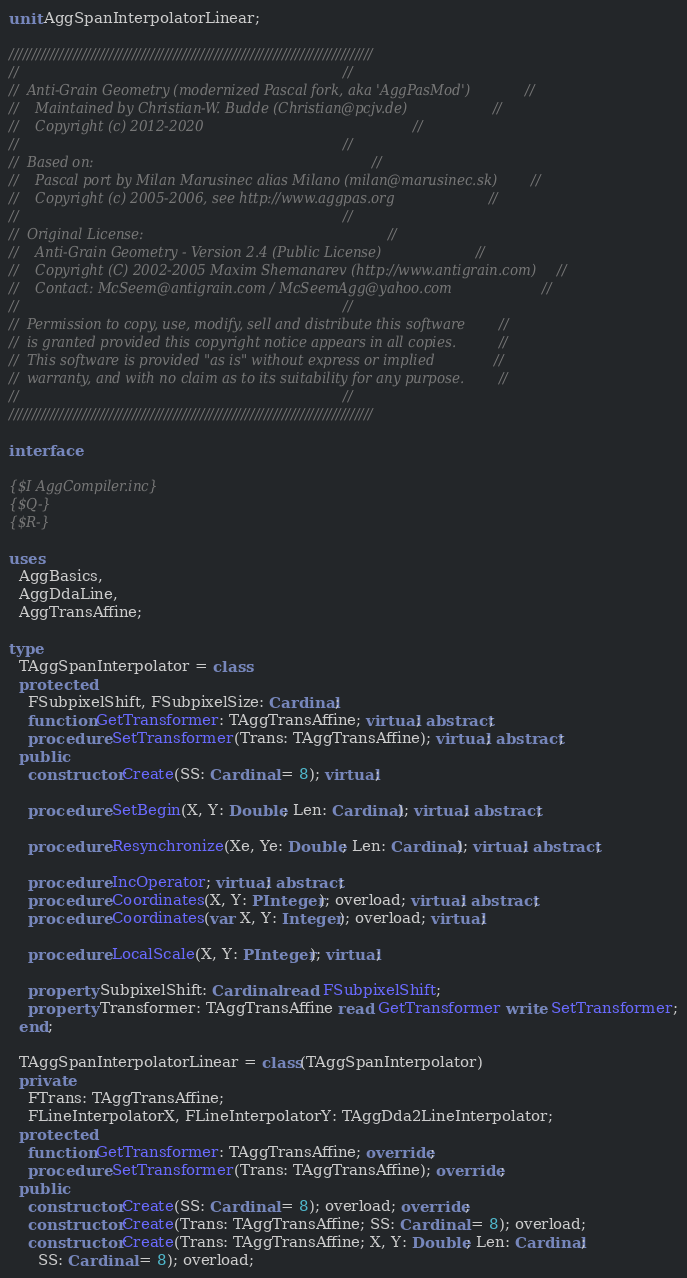Convert code to text. <code><loc_0><loc_0><loc_500><loc_500><_Pascal_>unit AggSpanInterpolatorLinear;

////////////////////////////////////////////////////////////////////////////////
//                                                                            //
//  Anti-Grain Geometry (modernized Pascal fork, aka 'AggPasMod')             //
//    Maintained by Christian-W. Budde (Christian@pcjv.de)                    //
//    Copyright (c) 2012-2020                                                 //
//                                                                            //
//  Based on:                                                                 //
//    Pascal port by Milan Marusinec alias Milano (milan@marusinec.sk)        //
//    Copyright (c) 2005-2006, see http://www.aggpas.org                      //
//                                                                            //
//  Original License:                                                         //
//    Anti-Grain Geometry - Version 2.4 (Public License)                      //
//    Copyright (C) 2002-2005 Maxim Shemanarev (http://www.antigrain.com)     //
//    Contact: McSeem@antigrain.com / McSeemAgg@yahoo.com                     //
//                                                                            //
//  Permission to copy, use, modify, sell and distribute this software        //
//  is granted provided this copyright notice appears in all copies.          //
//  This software is provided "as is" without express or implied              //
//  warranty, and with no claim as to its suitability for any purpose.        //
//                                                                            //
////////////////////////////////////////////////////////////////////////////////

interface

{$I AggCompiler.inc}
{$Q-}
{$R-}

uses
  AggBasics,
  AggDdaLine,
  AggTransAffine;

type
  TAggSpanInterpolator = class
  protected
    FSubpixelShift, FSubpixelSize: Cardinal;
    function GetTransformer: TAggTransAffine; virtual; abstract;
    procedure SetTransformer(Trans: TAggTransAffine); virtual; abstract;
  public
    constructor Create(SS: Cardinal = 8); virtual;

    procedure SetBegin(X, Y: Double; Len: Cardinal); virtual; abstract;

    procedure Resynchronize(Xe, Ye: Double; Len: Cardinal); virtual; abstract;

    procedure IncOperator; virtual; abstract;
    procedure Coordinates(X, Y: PInteger); overload; virtual; abstract;
    procedure Coordinates(var X, Y: Integer); overload; virtual;

    procedure LocalScale(X, Y: PInteger); virtual;

    property SubpixelShift: Cardinal read FSubpixelShift;
    property Transformer: TAggTransAffine read GetTransformer write SetTransformer;
  end;

  TAggSpanInterpolatorLinear = class(TAggSpanInterpolator)
  private
    FTrans: TAggTransAffine;
    FLineInterpolatorX, FLineInterpolatorY: TAggDda2LineInterpolator;
  protected
    function GetTransformer: TAggTransAffine; override;
    procedure SetTransformer(Trans: TAggTransAffine); override;
  public
    constructor Create(SS: Cardinal = 8); overload; override;
    constructor Create(Trans: TAggTransAffine; SS: Cardinal = 8); overload;
    constructor Create(Trans: TAggTransAffine; X, Y: Double; Len: Cardinal;
      SS: Cardinal = 8); overload;
</code> 